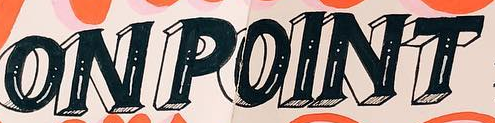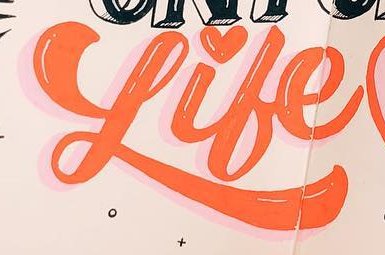Read the text content from these images in order, separated by a semicolon. ONPOINT; Like 